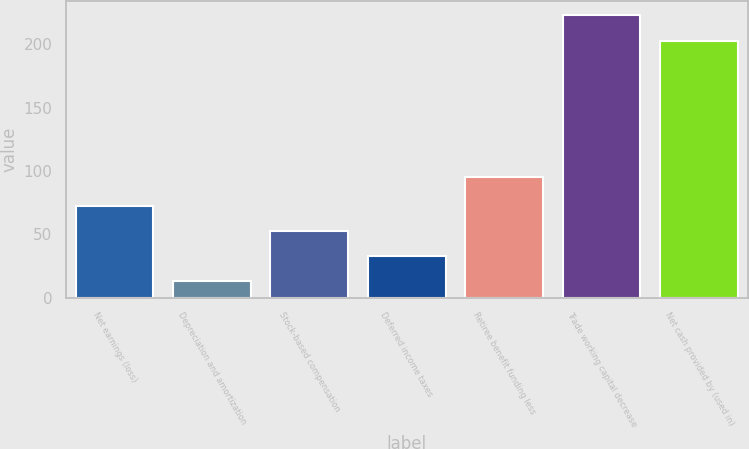<chart> <loc_0><loc_0><loc_500><loc_500><bar_chart><fcel>Net earnings (loss)<fcel>Depreciation and amortization<fcel>Stock-based compensation<fcel>Deferred income taxes<fcel>Retiree benefit funding less<fcel>Trade working capital decrease<fcel>Net cash provided by (used in)<nl><fcel>72.4<fcel>13<fcel>52.6<fcel>32.8<fcel>95<fcel>222.8<fcel>203<nl></chart> 